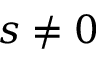<formula> <loc_0><loc_0><loc_500><loc_500>s \neq 0</formula> 